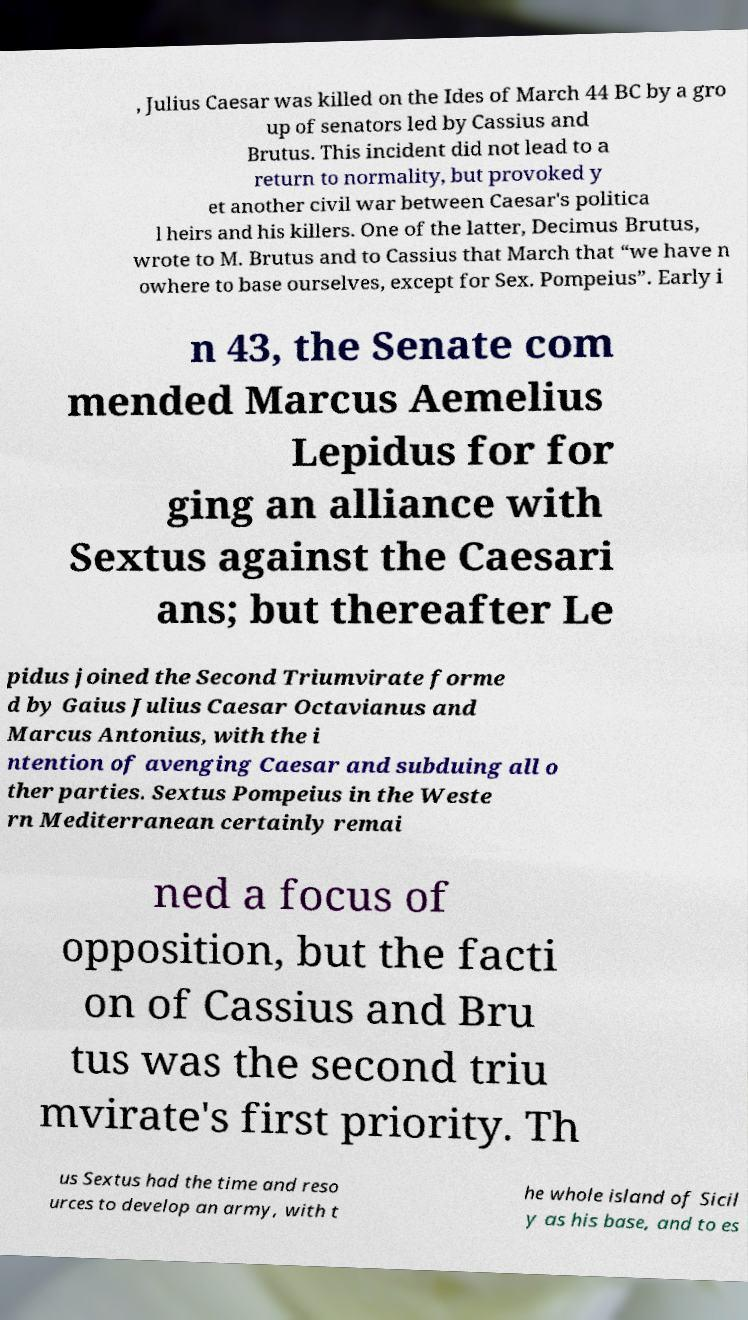For documentation purposes, I need the text within this image transcribed. Could you provide that? , Julius Caesar was killed on the Ides of March 44 BC by a gro up of senators led by Cassius and Brutus. This incident did not lead to a return to normality, but provoked y et another civil war between Caesar's politica l heirs and his killers. One of the latter, Decimus Brutus, wrote to M. Brutus and to Cassius that March that “we have n owhere to base ourselves, except for Sex. Pompeius”. Early i n 43, the Senate com mended Marcus Aemelius Lepidus for for ging an alliance with Sextus against the Caesari ans; but thereafter Le pidus joined the Second Triumvirate forme d by Gaius Julius Caesar Octavianus and Marcus Antonius, with the i ntention of avenging Caesar and subduing all o ther parties. Sextus Pompeius in the Weste rn Mediterranean certainly remai ned a focus of opposition, but the facti on of Cassius and Bru tus was the second triu mvirate's first priority. Th us Sextus had the time and reso urces to develop an army, with t he whole island of Sicil y as his base, and to es 